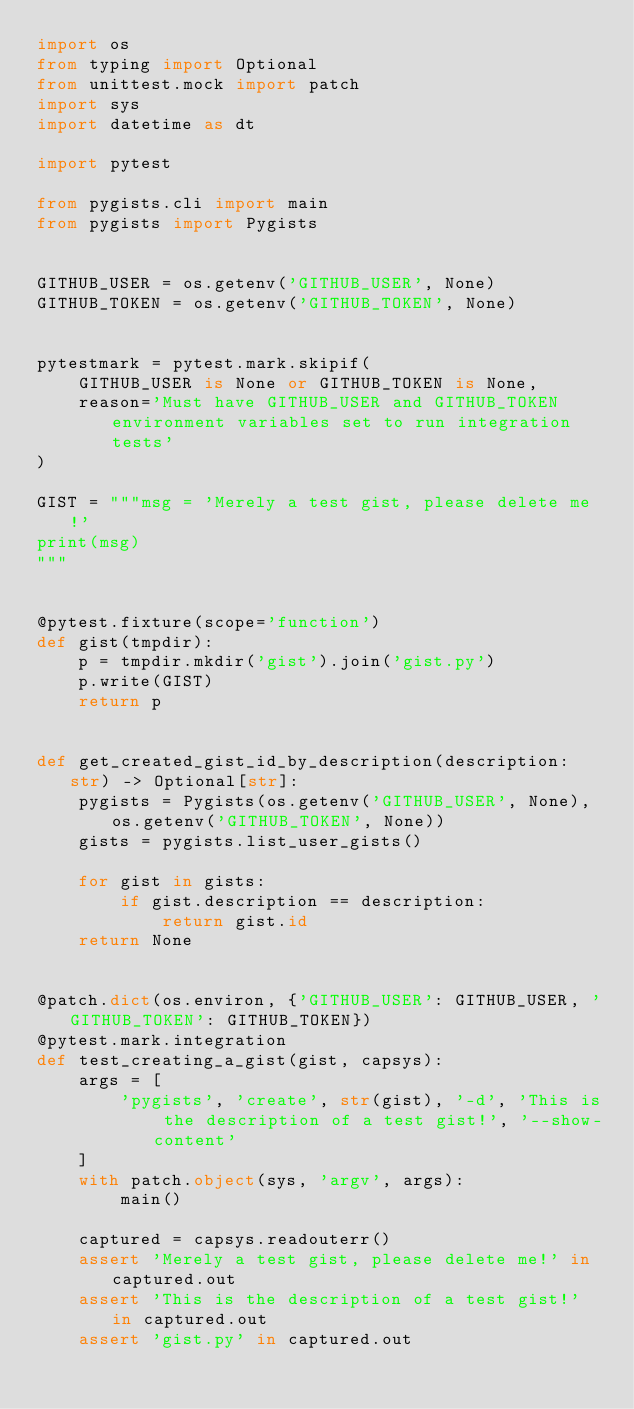Convert code to text. <code><loc_0><loc_0><loc_500><loc_500><_Python_>import os
from typing import Optional
from unittest.mock import patch
import sys
import datetime as dt

import pytest

from pygists.cli import main
from pygists import Pygists


GITHUB_USER = os.getenv('GITHUB_USER', None)
GITHUB_TOKEN = os.getenv('GITHUB_TOKEN', None)


pytestmark = pytest.mark.skipif(
    GITHUB_USER is None or GITHUB_TOKEN is None,
    reason='Must have GITHUB_USER and GITHUB_TOKEN environment variables set to run integration tests'
)

GIST = """msg = 'Merely a test gist, please delete me!'
print(msg)
"""


@pytest.fixture(scope='function')
def gist(tmpdir):
    p = tmpdir.mkdir('gist').join('gist.py')
    p.write(GIST)
    return p


def get_created_gist_id_by_description(description: str) -> Optional[str]:
    pygists = Pygists(os.getenv('GITHUB_USER', None), os.getenv('GITHUB_TOKEN', None))
    gists = pygists.list_user_gists()

    for gist in gists:
        if gist.description == description:
            return gist.id
    return None


@patch.dict(os.environ, {'GITHUB_USER': GITHUB_USER, 'GITHUB_TOKEN': GITHUB_TOKEN})
@pytest.mark.integration
def test_creating_a_gist(gist, capsys):
    args = [
        'pygists', 'create', str(gist), '-d', 'This is the description of a test gist!', '--show-content'
    ]
    with patch.object(sys, 'argv', args):
        main()

    captured = capsys.readouterr()
    assert 'Merely a test gist, please delete me!' in captured.out
    assert 'This is the description of a test gist!' in captured.out
    assert 'gist.py' in captured.out</code> 